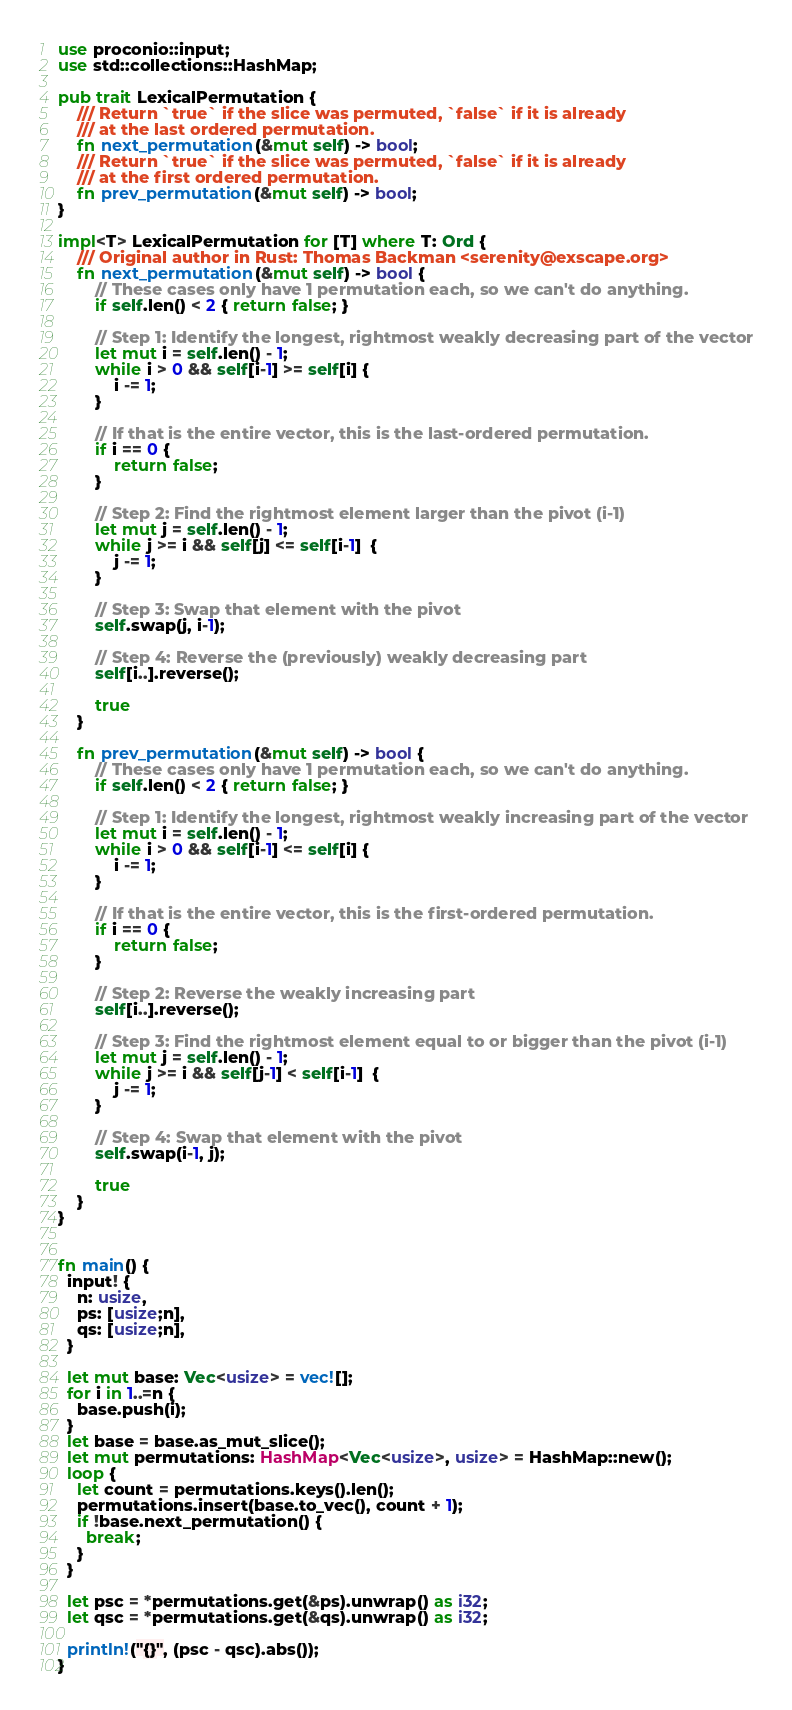<code> <loc_0><loc_0><loc_500><loc_500><_Rust_>use proconio::input;
use std::collections::HashMap;

pub trait LexicalPermutation {
    /// Return `true` if the slice was permuted, `false` if it is already
    /// at the last ordered permutation.
    fn next_permutation(&mut self) -> bool;
    /// Return `true` if the slice was permuted, `false` if it is already
    /// at the first ordered permutation.
    fn prev_permutation(&mut self) -> bool;
}

impl<T> LexicalPermutation for [T] where T: Ord {
    /// Original author in Rust: Thomas Backman <serenity@exscape.org>
    fn next_permutation(&mut self) -> bool {
        // These cases only have 1 permutation each, so we can't do anything.
        if self.len() < 2 { return false; }

        // Step 1: Identify the longest, rightmost weakly decreasing part of the vector
        let mut i = self.len() - 1;
        while i > 0 && self[i-1] >= self[i] {
            i -= 1;
        }

        // If that is the entire vector, this is the last-ordered permutation.
        if i == 0 {
            return false;
        }

        // Step 2: Find the rightmost element larger than the pivot (i-1)
        let mut j = self.len() - 1;
        while j >= i && self[j] <= self[i-1]  {
            j -= 1;
        }

        // Step 3: Swap that element with the pivot
        self.swap(j, i-1);

        // Step 4: Reverse the (previously) weakly decreasing part
        self[i..].reverse();

        true
    }

    fn prev_permutation(&mut self) -> bool {
        // These cases only have 1 permutation each, so we can't do anything.
        if self.len() < 2 { return false; }

        // Step 1: Identify the longest, rightmost weakly increasing part of the vector
        let mut i = self.len() - 1;
        while i > 0 && self[i-1] <= self[i] {
            i -= 1;
        }

        // If that is the entire vector, this is the first-ordered permutation.
        if i == 0 {
            return false;
        }

        // Step 2: Reverse the weakly increasing part
        self[i..].reverse();

        // Step 3: Find the rightmost element equal to or bigger than the pivot (i-1)
        let mut j = self.len() - 1;
        while j >= i && self[j-1] < self[i-1]  {
            j -= 1;
        }

        // Step 4: Swap that element with the pivot
        self.swap(i-1, j);

        true
    }
}


fn main() {
  input! {
    n: usize,
    ps: [usize;n],
    qs: [usize;n],
  }
  
  let mut base: Vec<usize> = vec![];
  for i in 1..=n {
    base.push(i);
  }
  let base = base.as_mut_slice();
  let mut permutations: HashMap<Vec<usize>, usize> = HashMap::new();
  loop {
    let count = permutations.keys().len();
    permutations.insert(base.to_vec(), count + 1);
    if !base.next_permutation() {
      break;
    }
  }
  
  let psc = *permutations.get(&ps).unwrap() as i32;
  let qsc = *permutations.get(&qs).unwrap() as i32;  
  
  println!("{}", (psc - qsc).abs());
}</code> 